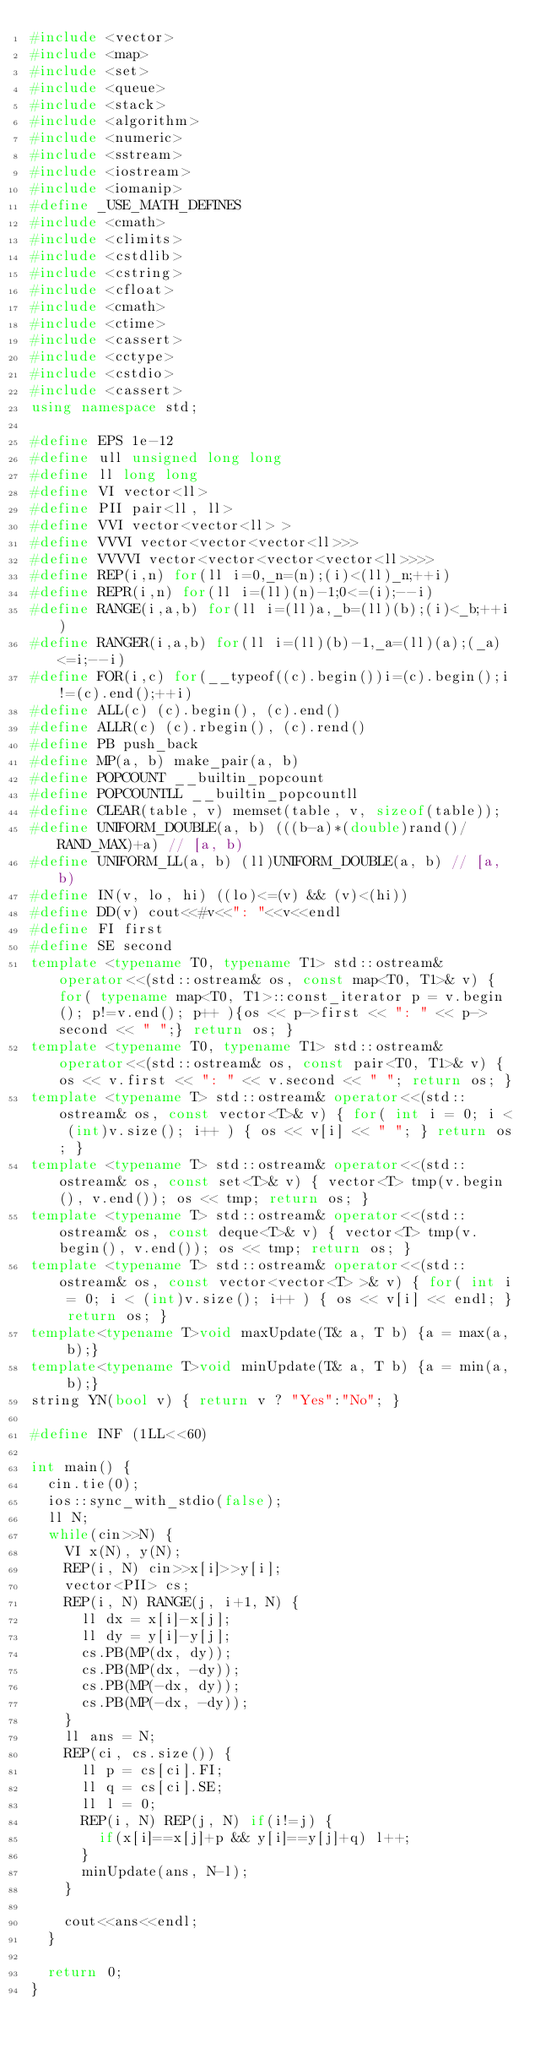Convert code to text. <code><loc_0><loc_0><loc_500><loc_500><_C++_>#include <vector>
#include <map>
#include <set>
#include <queue>
#include <stack>
#include <algorithm>
#include <numeric>
#include <sstream>
#include <iostream>
#include <iomanip>
#define _USE_MATH_DEFINES
#include <cmath>
#include <climits>
#include <cstdlib>
#include <cstring>
#include <cfloat>
#include <cmath>
#include <ctime>
#include <cassert>
#include <cctype>
#include <cstdio>
#include <cassert>
using namespace std;

#define EPS 1e-12
#define ull unsigned long long
#define ll long long
#define VI vector<ll>
#define PII pair<ll, ll> 
#define VVI vector<vector<ll> >
#define VVVI vector<vector<vector<ll>>>
#define VVVVI vector<vector<vector<vector<ll>>>>
#define REP(i,n) for(ll i=0,_n=(n);(i)<(ll)_n;++i)
#define REPR(i,n) for(ll i=(ll)(n)-1;0<=(i);--i)
#define RANGE(i,a,b) for(ll i=(ll)a,_b=(ll)(b);(i)<_b;++i)
#define RANGER(i,a,b) for(ll i=(ll)(b)-1,_a=(ll)(a);(_a)<=i;--i)
#define FOR(i,c) for(__typeof((c).begin())i=(c).begin();i!=(c).end();++i)
#define ALL(c) (c).begin(), (c).end()
#define ALLR(c) (c).rbegin(), (c).rend()
#define PB push_back
#define MP(a, b) make_pair(a, b)
#define POPCOUNT __builtin_popcount
#define POPCOUNTLL __builtin_popcountll
#define CLEAR(table, v) memset(table, v, sizeof(table));
#define UNIFORM_DOUBLE(a, b) (((b-a)*(double)rand()/RAND_MAX)+a) // [a, b) 
#define UNIFORM_LL(a, b) (ll)UNIFORM_DOUBLE(a, b) // [a, b) 
#define IN(v, lo, hi) ((lo)<=(v) && (v)<(hi))
#define DD(v) cout<<#v<<": "<<v<<endl
#define FI first
#define SE second
template <typename T0, typename T1> std::ostream& operator<<(std::ostream& os, const map<T0, T1>& v) { for( typename map<T0, T1>::const_iterator p = v.begin(); p!=v.end(); p++ ){os << p->first << ": " << p->second << " ";} return os; }
template <typename T0, typename T1> std::ostream& operator<<(std::ostream& os, const pair<T0, T1>& v) { os << v.first << ": " << v.second << " "; return os; }
template <typename T> std::ostream& operator<<(std::ostream& os, const vector<T>& v) { for( int i = 0; i < (int)v.size(); i++ ) { os << v[i] << " "; } return os; }
template <typename T> std::ostream& operator<<(std::ostream& os, const set<T>& v) { vector<T> tmp(v.begin(), v.end()); os << tmp; return os; }
template <typename T> std::ostream& operator<<(std::ostream& os, const deque<T>& v) { vector<T> tmp(v.begin(), v.end()); os << tmp; return os; }
template <typename T> std::ostream& operator<<(std::ostream& os, const vector<vector<T> >& v) { for( int i = 0; i < (int)v.size(); i++ ) { os << v[i] << endl; } return os; }
template<typename T>void maxUpdate(T& a, T b) {a = max(a, b);}
template<typename T>void minUpdate(T& a, T b) {a = min(a, b);}
string YN(bool v) { return v ? "Yes":"No"; }

#define INF (1LL<<60)

int main() {
	cin.tie(0);
	ios::sync_with_stdio(false);
	ll N;
	while(cin>>N) {
		VI x(N), y(N);
		REP(i, N) cin>>x[i]>>y[i];
		vector<PII> cs;
		REP(i, N) RANGE(j, i+1, N) {
			ll dx = x[i]-x[j];
			ll dy = y[i]-y[j];
			cs.PB(MP(dx, dy));
			cs.PB(MP(dx, -dy));
			cs.PB(MP(-dx, dy));
			cs.PB(MP(-dx, -dy));
		}
		ll ans = N;
		REP(ci, cs.size()) {
			ll p = cs[ci].FI;
			ll q = cs[ci].SE;
			ll l = 0;
			REP(i, N) REP(j, N) if(i!=j) {
				if(x[i]==x[j]+p && y[i]==y[j]+q) l++;
			}
			minUpdate(ans, N-l);
		}
		
		cout<<ans<<endl;
	}
	
	return 0;
}
</code> 